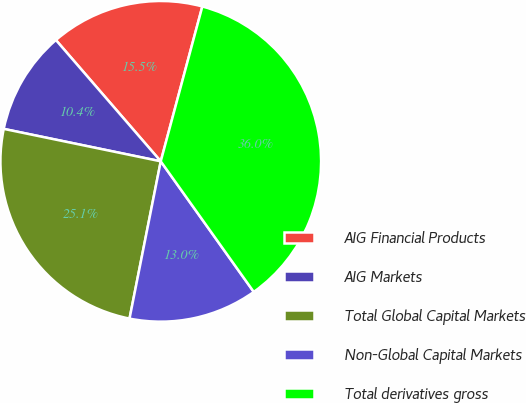<chart> <loc_0><loc_0><loc_500><loc_500><pie_chart><fcel>AIG Financial Products<fcel>AIG Markets<fcel>Total Global Capital Markets<fcel>Non-Global Capital Markets<fcel>Total derivatives gross<nl><fcel>15.52%<fcel>10.41%<fcel>25.12%<fcel>12.97%<fcel>35.97%<nl></chart> 